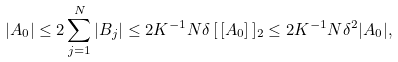<formula> <loc_0><loc_0><loc_500><loc_500>| A _ { 0 } | \leq 2 \sum _ { j = 1 } ^ { N } | B _ { j } | \leq 2 K ^ { - 1 } N \delta \, [ \, [ A _ { 0 } ] \, ] _ { 2 } \leq 2 K ^ { - 1 } N \delta ^ { 2 } | A _ { 0 } | ,</formula> 